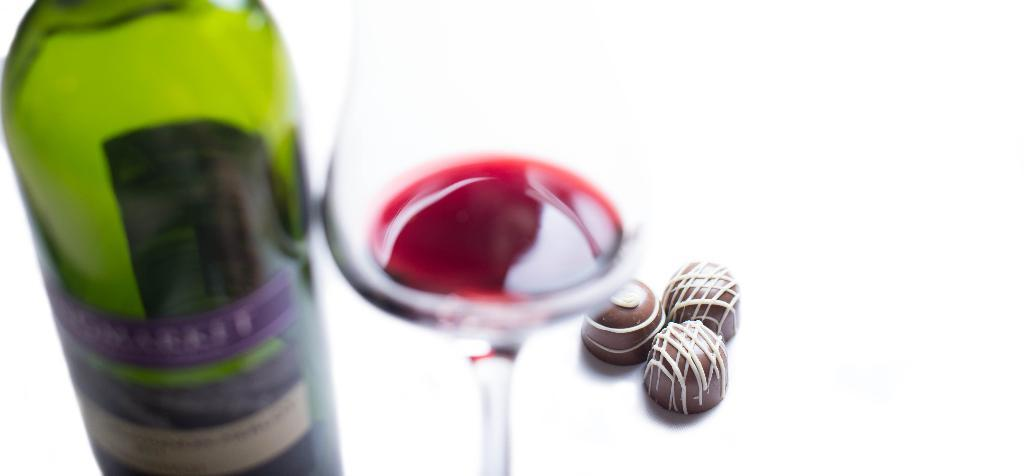What is one object visible in the image? There is a bottle in the image. What is another object visible in the image? There is a glass in the image. What can be observed about the bottle in the image? The bottle has a label. What information can be found on the label? The label contains some text. What type of prose is written on the hair in the image? There is no hair or prose present in the image. What is being served for breakfast in the image? The image does not show any food or breakfast items. 